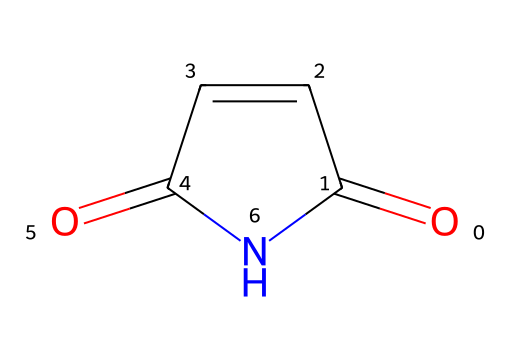What is the main functional group present in this structure? The structure contains a carbonyl group (C=O) that is characteristic of imides, noticeable at the end of the cyclic structure.
Answer: carbonyl How many nitrogen atoms are present in this chemical? By inspecting the SMILES representation and the rendered structure, we can see only one nitrogen atom is present.
Answer: one What is the total number of rings in this molecule? The structure shows that there is a cyclic arrangement, indicating that there is one ring present in the molecule.
Answer: one Which type of chemical classification does this compound belong to? The presence of both a carbonyl and a nitrogen in a cyclic form defines it as an imide.
Answer: imide What is the hybridization of the nitrogen atom in this compound? The nitrogen atom is bonded to two carbon atoms and does not have a lone pair affecting its hybridization, indicating it is sp2 hybridized.
Answer: sp2 Are there any double bonds present in this molecule? The representation shows the presence of double bonds between carbon and oxygen, as well as carbon-carbon, confirming multiple instances of double bonds in the structure.
Answer: yes 